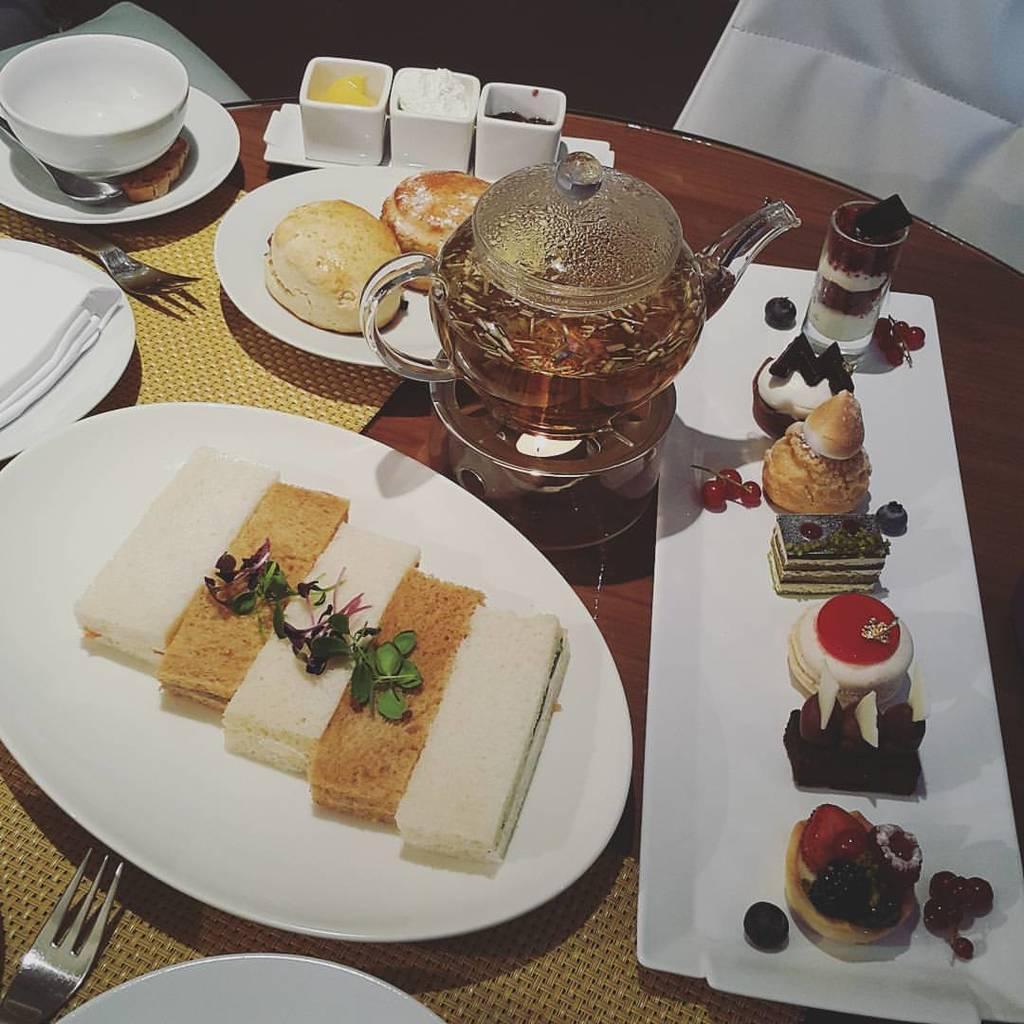Could you give a brief overview of what you see in this image? In this image there are plates, fork, bowls, tissues, glass, kettle, food on the table. There are white chairs behind the table. 